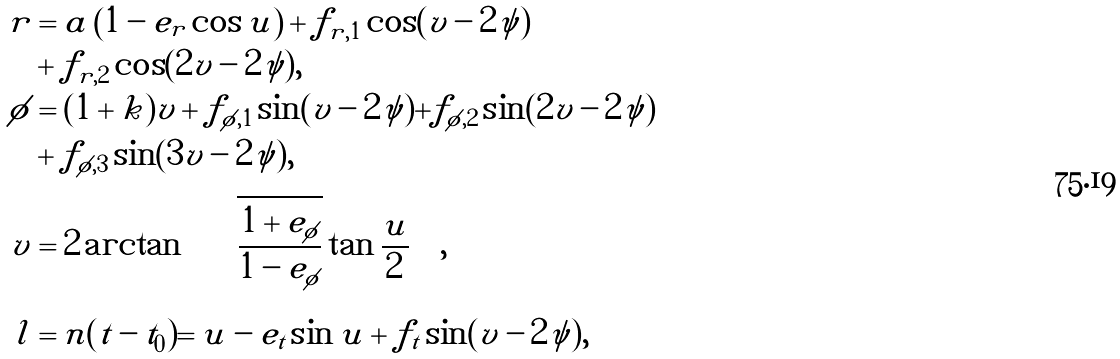<formula> <loc_0><loc_0><loc_500><loc_500>r & = a \left ( 1 - e _ { r } \cos u \right ) + f _ { r , 1 } \cos ( v - 2 \psi ) \\ & + f _ { r , 2 } \cos ( 2 v - 2 \psi ) , \\ \phi & = ( 1 + k ) v + f _ { \phi , 1 } \sin ( v - 2 \psi ) + f _ { \phi , 2 } \sin ( 2 v - 2 \psi ) \\ & + f _ { \phi , 3 } \sin ( 3 v - 2 \psi ) , \\ v & = 2 \arctan \left ( \sqrt { \frac { 1 + e _ { \phi } } { 1 - e _ { \phi } } } \tan \frac { u } { 2 } \right ) , \\ l & = n ( t - t _ { 0 } ) = u - e _ { t } \sin u + f _ { t } \sin ( v - 2 \psi ) ,</formula> 